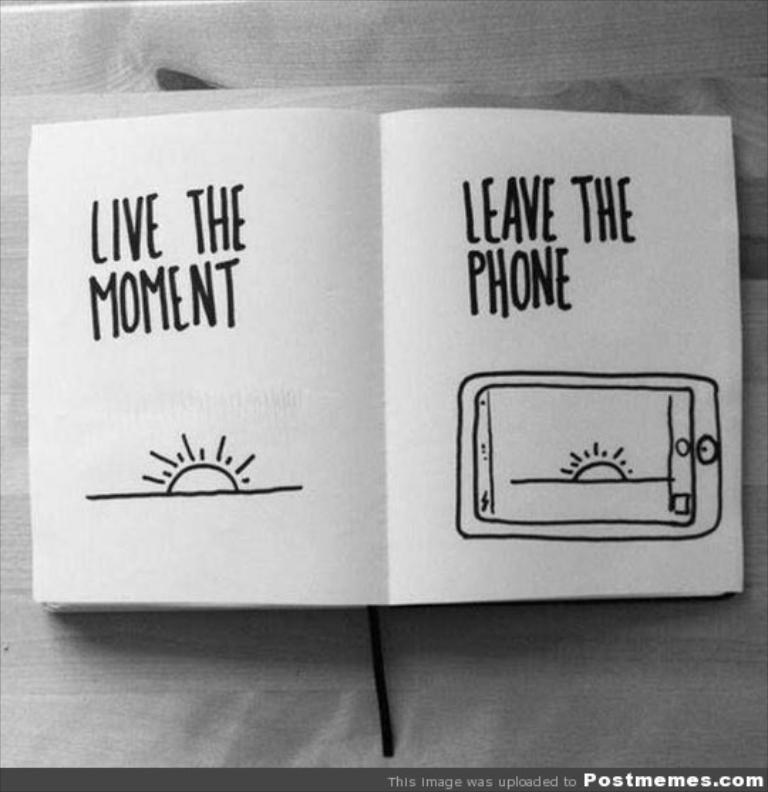What is the color scheme of the image? The image is black and white. What is the main object in the center of the image? There is a book in the center of the image. What can be found on the book? The book has text on it. Where is the book located in the image? The book is on a table. How many beds are visible in the image? There are no beds visible in the image; it features a book on a table. What type of cherry is being used as a bookmark in the image? There is no cherry present in the image, and the book does not have a bookmark. 